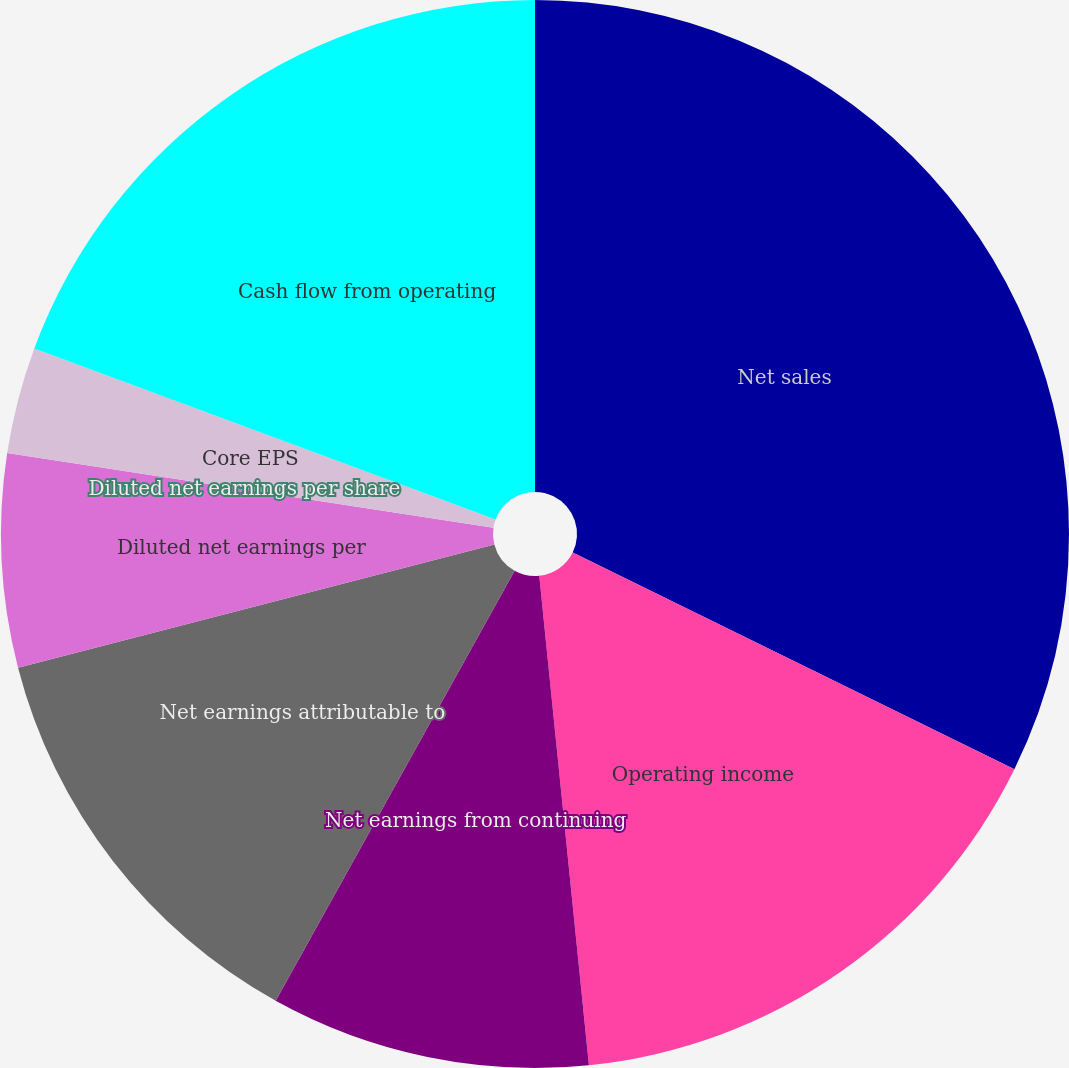<chart> <loc_0><loc_0><loc_500><loc_500><pie_chart><fcel>Net sales<fcel>Operating income<fcel>Net earnings from continuing<fcel>Net earnings attributable to<fcel>Diluted net earnings per<fcel>Diluted net earnings per share<fcel>Core EPS<fcel>Cash flow from operating<nl><fcel>32.26%<fcel>16.13%<fcel>9.68%<fcel>12.9%<fcel>6.45%<fcel>0.0%<fcel>3.23%<fcel>19.35%<nl></chart> 